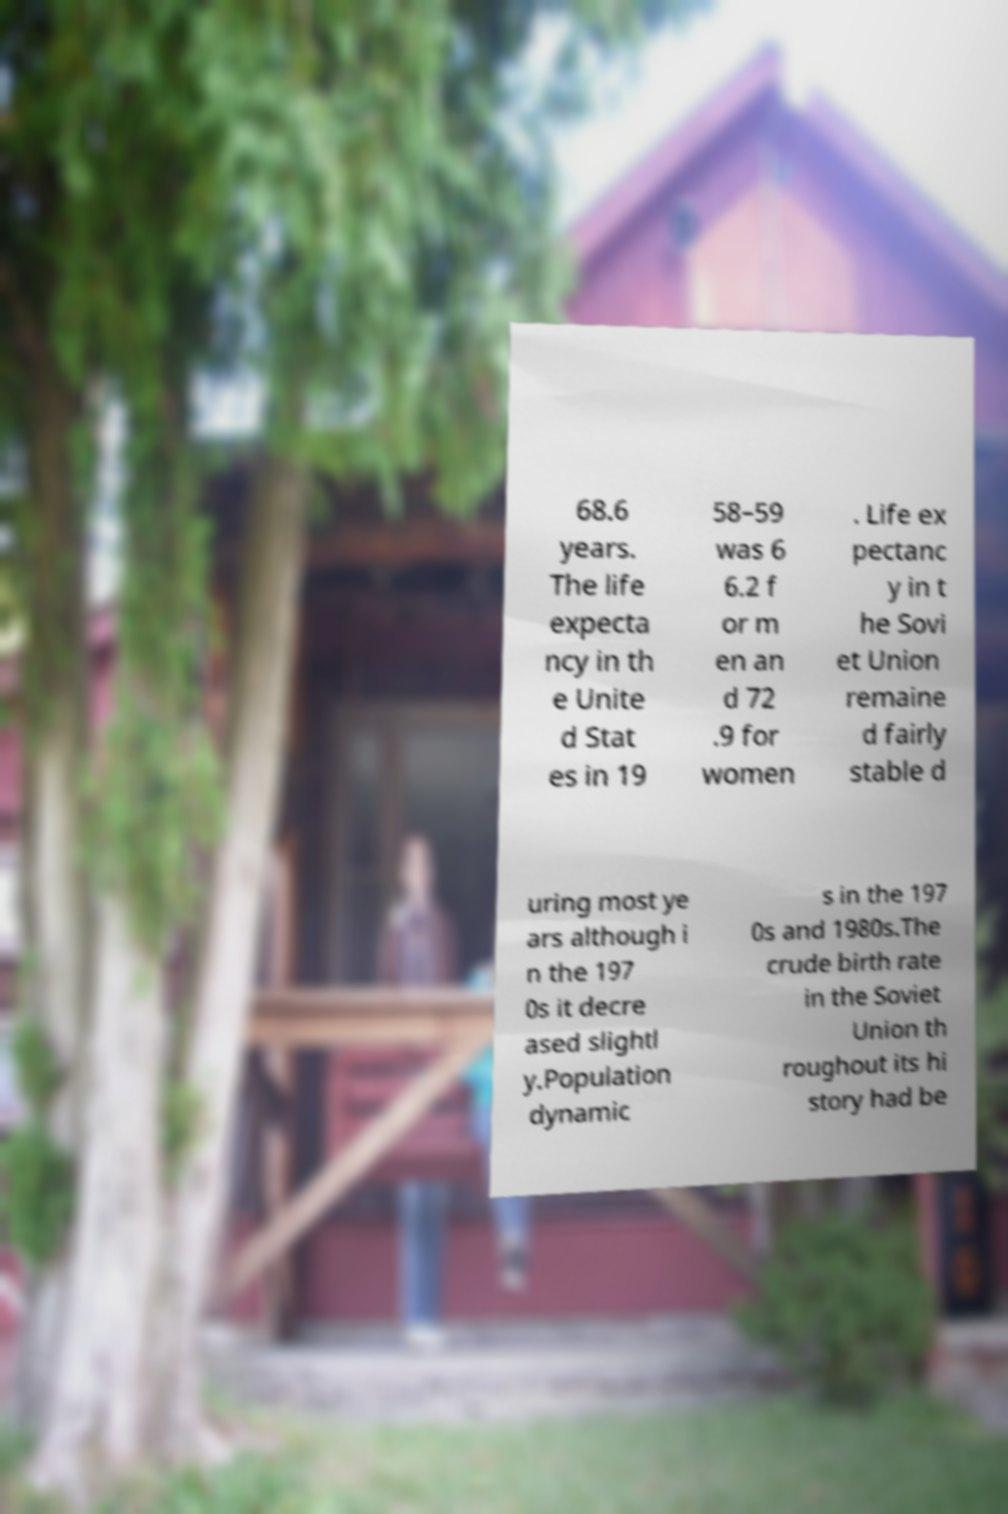For documentation purposes, I need the text within this image transcribed. Could you provide that? 68.6 years. The life expecta ncy in th e Unite d Stat es in 19 58–59 was 6 6.2 f or m en an d 72 .9 for women . Life ex pectanc y in t he Sovi et Union remaine d fairly stable d uring most ye ars although i n the 197 0s it decre ased slightl y.Population dynamic s in the 197 0s and 1980s.The crude birth rate in the Soviet Union th roughout its hi story had be 